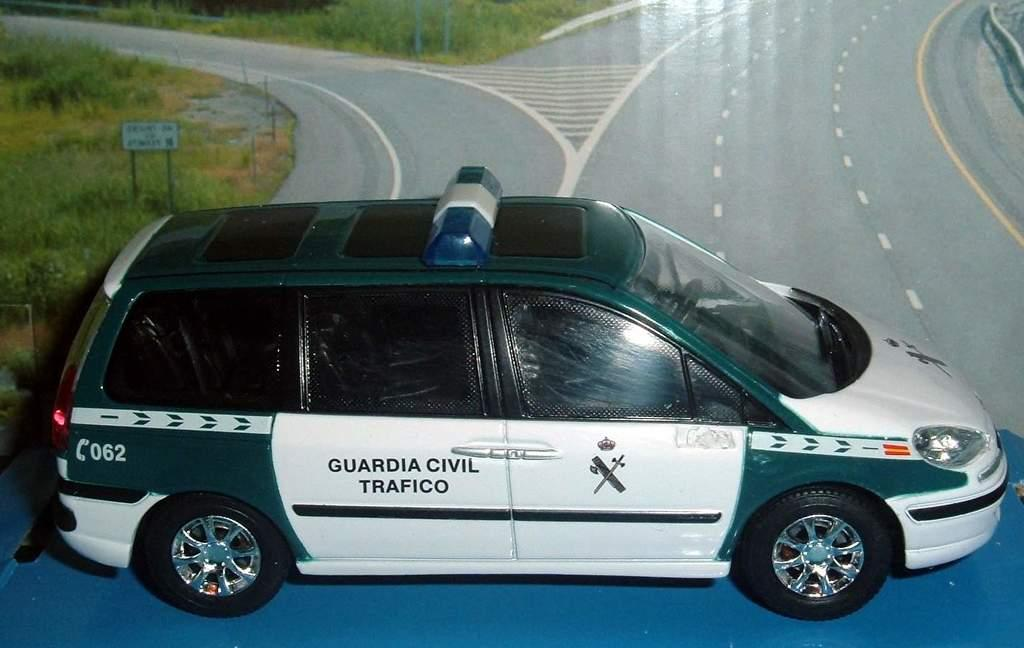<image>
Offer a succinct explanation of the picture presented. A black and white van has the logo for guardia civil trafico on its back door. 